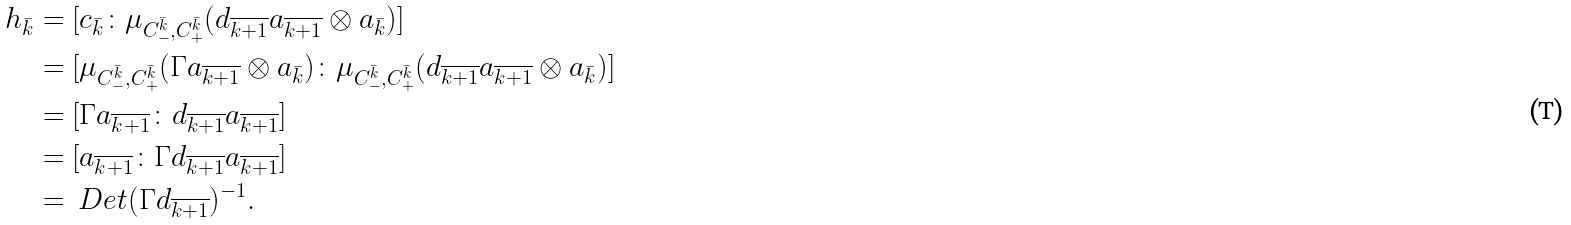Convert formula to latex. <formula><loc_0><loc_0><loc_500><loc_500>h _ { \bar { k } } & = [ c _ { \bar { k } } \colon \mu _ { C ^ { \bar { k } } _ { - } , C ^ { \bar { k } } _ { + } } ( d _ { \overline { k + 1 } } a _ { \overline { k + 1 } } \otimes a _ { \bar { k } } ) ] \\ & = [ \mu _ { C ^ { \bar { k } } _ { - } , C ^ { \bar { k } } _ { + } } ( \Gamma a _ { \overline { k + 1 } } \otimes a _ { \bar { k } } ) \colon \mu _ { C ^ { \bar { k } } _ { - } , C ^ { \bar { k } } _ { + } } ( d _ { \overline { k + 1 } } a _ { \overline { k + 1 } } \otimes a _ { \bar { k } } ) ] \\ & = [ \Gamma a _ { \overline { k + 1 } } \colon d _ { \overline { k + 1 } } a _ { \overline { k + 1 } } ] \\ & = [ a _ { \overline { k + 1 } } \colon \Gamma d _ { \overline { k + 1 } } a _ { \overline { k + 1 } } ] \\ & = \ D e t ( \Gamma d _ { \overline { k + 1 } } ) ^ { - 1 } .</formula> 